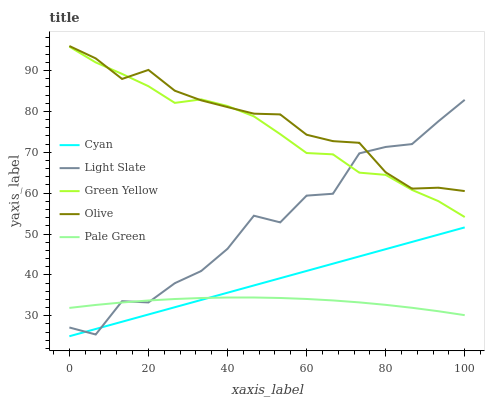Does Pale Green have the minimum area under the curve?
Answer yes or no. Yes. Does Olive have the maximum area under the curve?
Answer yes or no. Yes. Does Cyan have the minimum area under the curve?
Answer yes or no. No. Does Cyan have the maximum area under the curve?
Answer yes or no. No. Is Cyan the smoothest?
Answer yes or no. Yes. Is Light Slate the roughest?
Answer yes or no. Yes. Is Pale Green the smoothest?
Answer yes or no. No. Is Pale Green the roughest?
Answer yes or no. No. Does Cyan have the lowest value?
Answer yes or no. Yes. Does Pale Green have the lowest value?
Answer yes or no. No. Does Olive have the highest value?
Answer yes or no. Yes. Does Cyan have the highest value?
Answer yes or no. No. Is Pale Green less than Green Yellow?
Answer yes or no. Yes. Is Olive greater than Cyan?
Answer yes or no. Yes. Does Light Slate intersect Pale Green?
Answer yes or no. Yes. Is Light Slate less than Pale Green?
Answer yes or no. No. Is Light Slate greater than Pale Green?
Answer yes or no. No. Does Pale Green intersect Green Yellow?
Answer yes or no. No. 